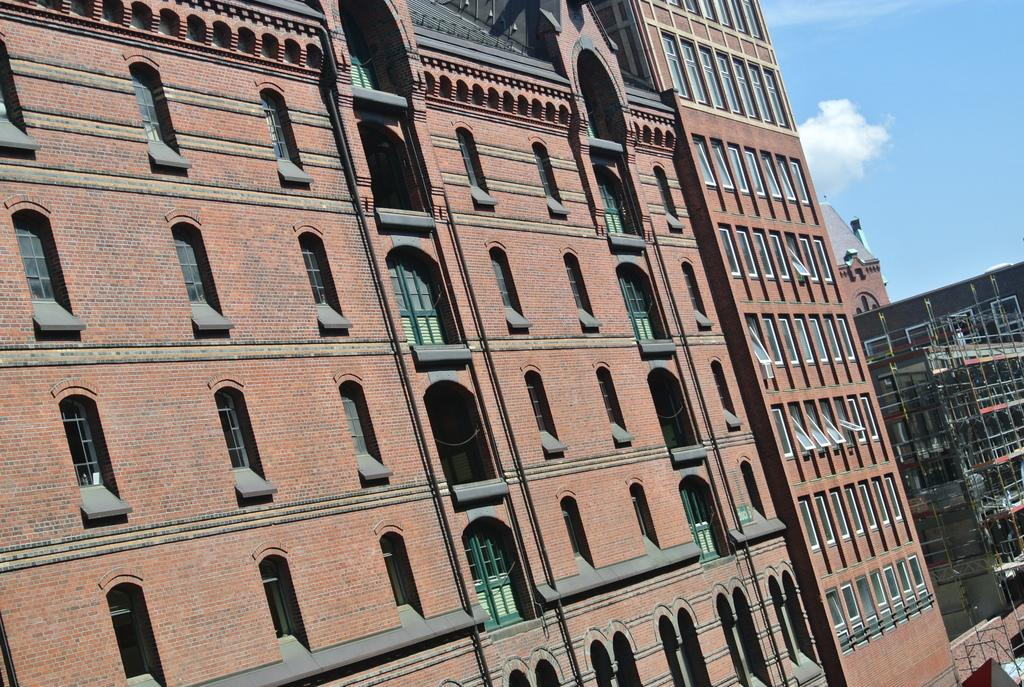What type of structures can be seen in the image? There are buildings in the image. What part of the natural environment is visible in the image? The sky is visible in the background of the image. How many cars are parked in front of the buildings in the image? There is no information about cars in the image; only buildings and the sky are mentioned. 